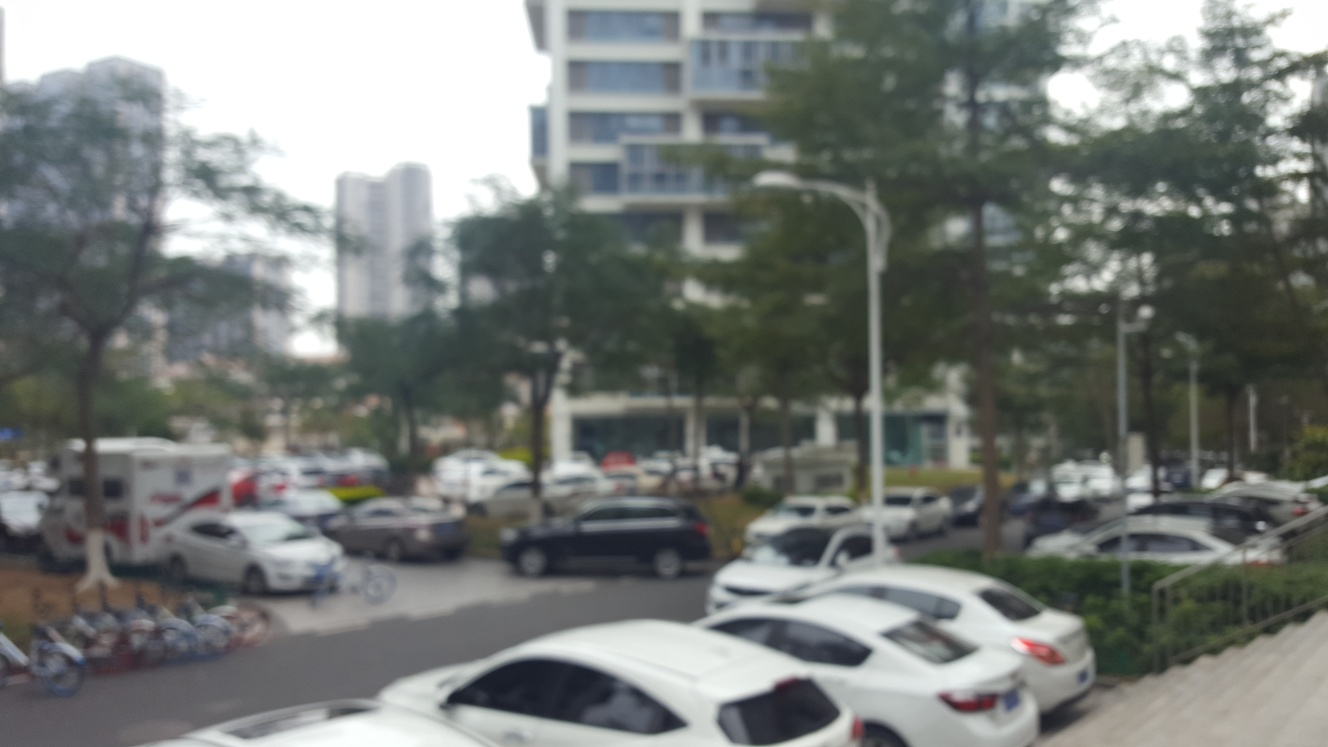Imagine this image in focus, what details might we expect to see in a cityscape like this? If this image were in focus, we could expect to see a variety of details that bring the cityscape to life. This might include the individual leaves on the trees, the distinct architectural features of the nearby buildings, clear signage, and the expressions and activities of any people present. The vehicles would have visible brand markings, and the overall sense of depth and space would be significantly enhanced. 